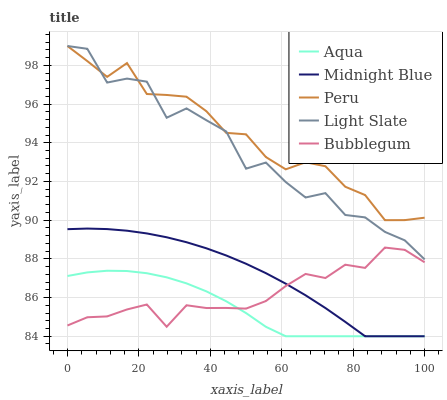Does Aqua have the minimum area under the curve?
Answer yes or no. Yes. Does Peru have the maximum area under the curve?
Answer yes or no. Yes. Does Bubblegum have the minimum area under the curve?
Answer yes or no. No. Does Bubblegum have the maximum area under the curve?
Answer yes or no. No. Is Midnight Blue the smoothest?
Answer yes or no. Yes. Is Light Slate the roughest?
Answer yes or no. Yes. Is Bubblegum the smoothest?
Answer yes or no. No. Is Bubblegum the roughest?
Answer yes or no. No. Does Bubblegum have the lowest value?
Answer yes or no. No. Does Peru have the highest value?
Answer yes or no. Yes. Does Bubblegum have the highest value?
Answer yes or no. No. Is Aqua less than Light Slate?
Answer yes or no. Yes. Is Peru greater than Bubblegum?
Answer yes or no. Yes. Does Midnight Blue intersect Bubblegum?
Answer yes or no. Yes. Is Midnight Blue less than Bubblegum?
Answer yes or no. No. Is Midnight Blue greater than Bubblegum?
Answer yes or no. No. Does Aqua intersect Light Slate?
Answer yes or no. No. 